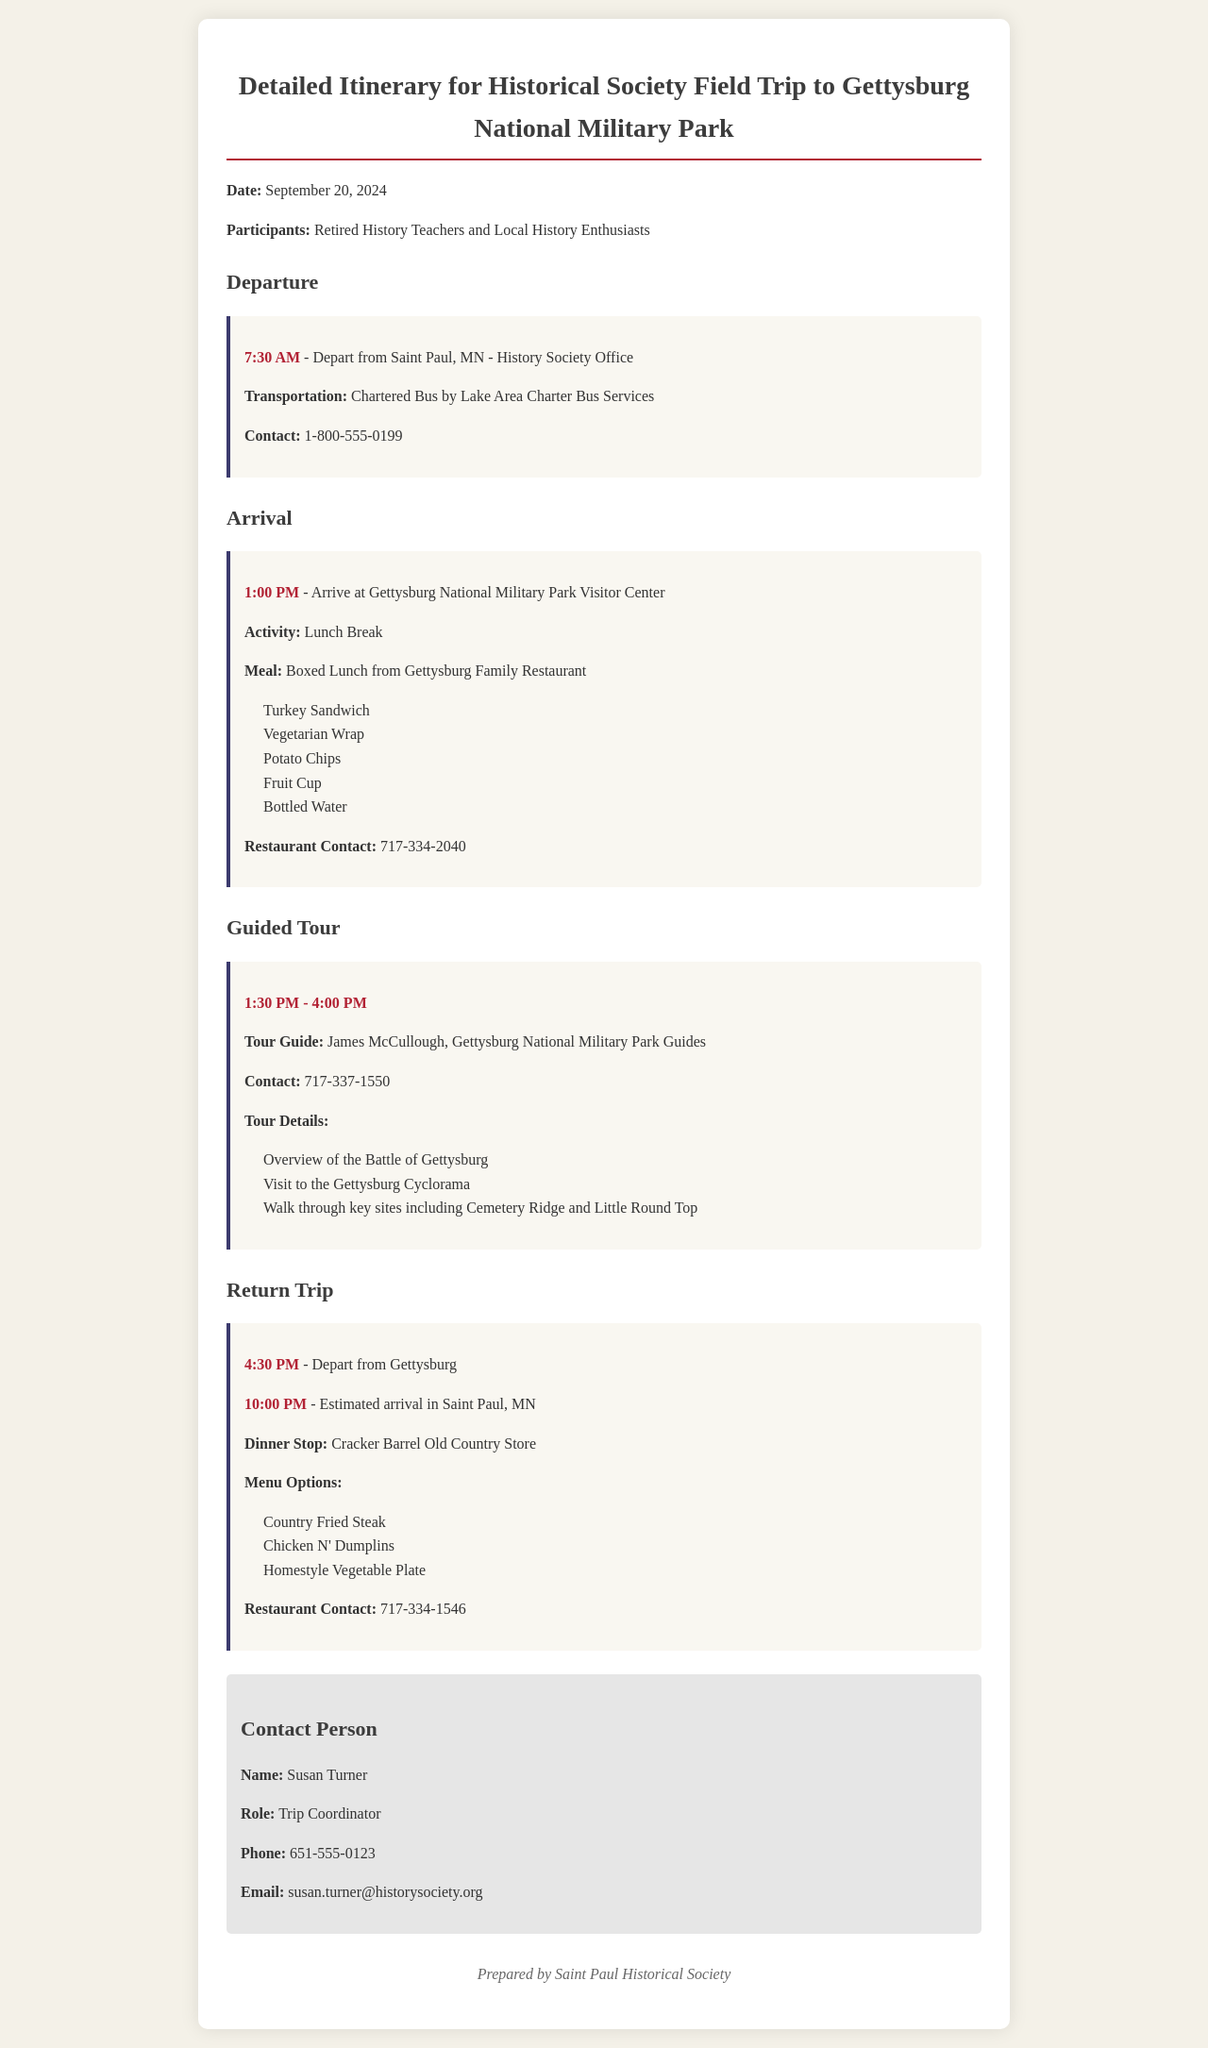What time do we depart from Saint Paul? The document states that departure from Saint Paul is scheduled for 7:30 AM.
Answer: 7:30 AM What meal is provided for lunch? The boxed lunch includes Turkey Sandwich, Vegetarian Wrap, Potato Chips, Fruit Cup, and Bottled Water as listed in the document.
Answer: Boxed Lunch from Gettysburg Family Restaurant Who is the tour guide for the battlefield tour? The tour guide for the guided tour is James McCullough, as mentioned in the itinerary.
Answer: James McCullough What time is the estimated arrival back in Saint Paul? The document specifies the estimated arrival time back in Saint Paul as 10:00 PM.
Answer: 10:00 PM What restaurant do we stop at for dinner? According to the schedule, the dinner stop is at Cracker Barrel Old Country Store.
Answer: Cracker Barrel Old Country Store How long is the guided tour? The guided tour lasts from 1:30 PM to 4:00 PM, which means it is 2 hours and 30 minutes long.
Answer: 2 hours and 30 minutes What is the contact number for the restaurant providing lunches? The contact number for Gettysburg Family Restaurant is listed in the itinerary as 717-334-2040.
Answer: 717-334-2040 Who is the trip coordinator? The name of the trip coordinator as mentioned in the contact information section is Susan Turner.
Answer: Susan Turner 